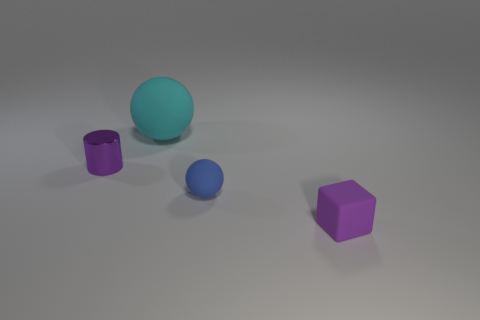Subtract all red spheres. Subtract all cyan blocks. How many spheres are left? 2 Add 2 tiny blue balls. How many objects exist? 6 Subtract all cylinders. How many objects are left? 3 Subtract 0 cyan cubes. How many objects are left? 4 Subtract all tiny green matte balls. Subtract all rubber spheres. How many objects are left? 2 Add 2 big cyan rubber things. How many big cyan rubber things are left? 3 Add 1 small purple shiny things. How many small purple shiny things exist? 2 